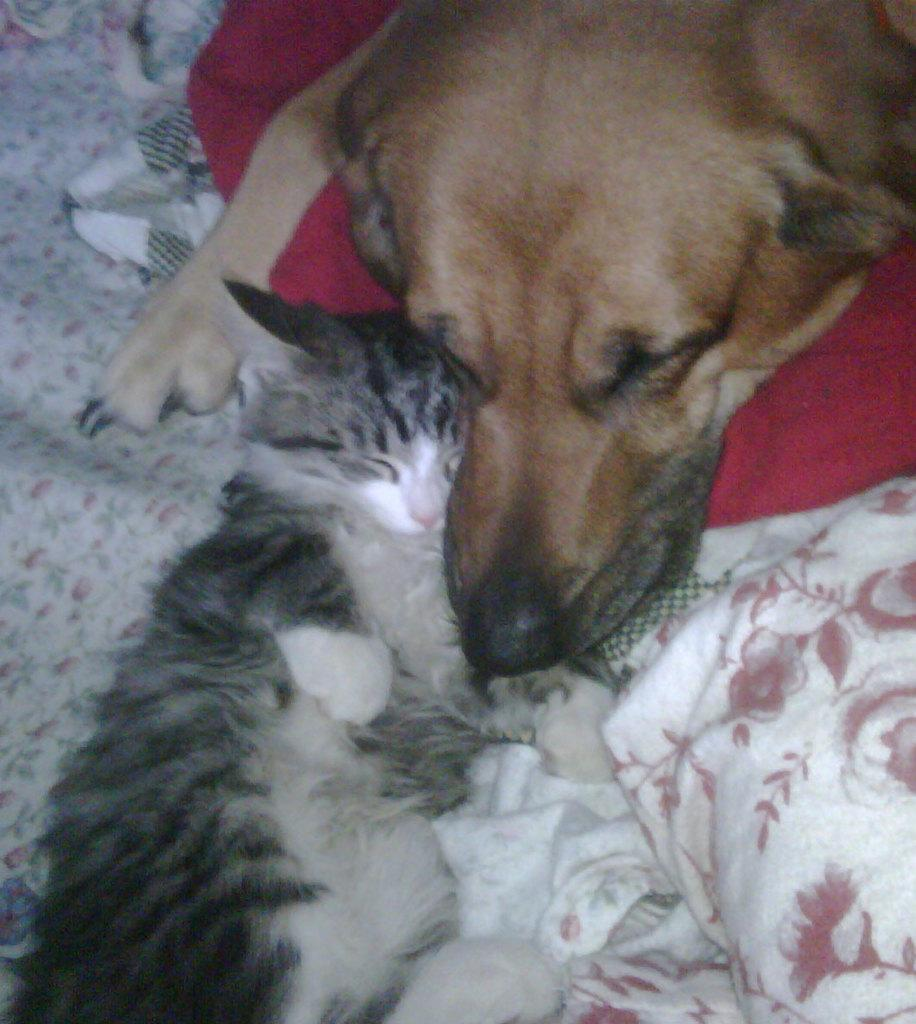What animals are present in the image? There is a cat and a dog in the image. Where are the cat and dog located? Both the cat and dog are on a mat. Are there any other mats visible in the image? Yes, there is another mat beside the dog. What type of authority does the gold have in the image? There is no gold present in the image, so it cannot have any authority. 